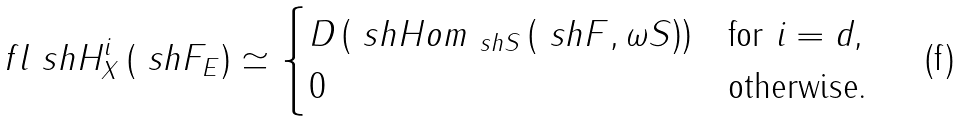<formula> <loc_0><loc_0><loc_500><loc_500>\ f l \ s h H _ { X } ^ { i } \left ( \ s h F _ { E } \right ) \simeq \begin{cases} D \left ( \ s h H o m _ { \ s h S } \left ( \ s h F , \omega S \right ) \right ) & \text {for $i = d$,} \\ 0 & \text {otherwise.} \end{cases}</formula> 